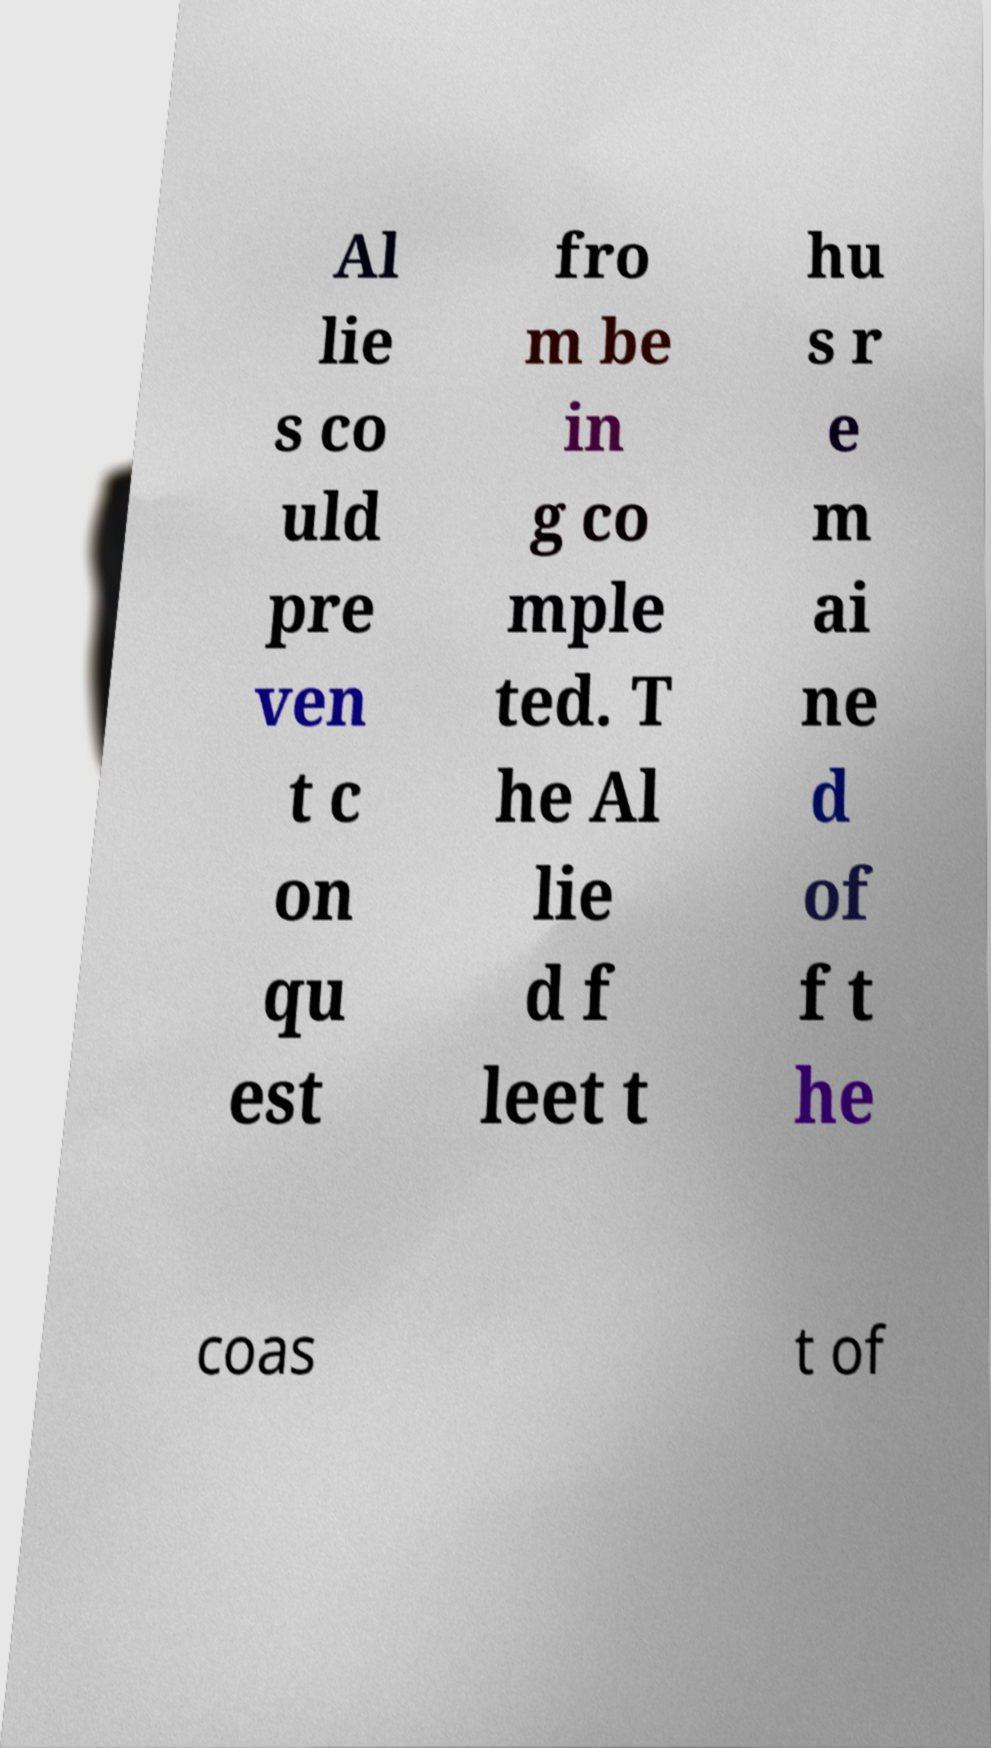Could you assist in decoding the text presented in this image and type it out clearly? Al lie s co uld pre ven t c on qu est fro m be in g co mple ted. T he Al lie d f leet t hu s r e m ai ne d of f t he coas t of 